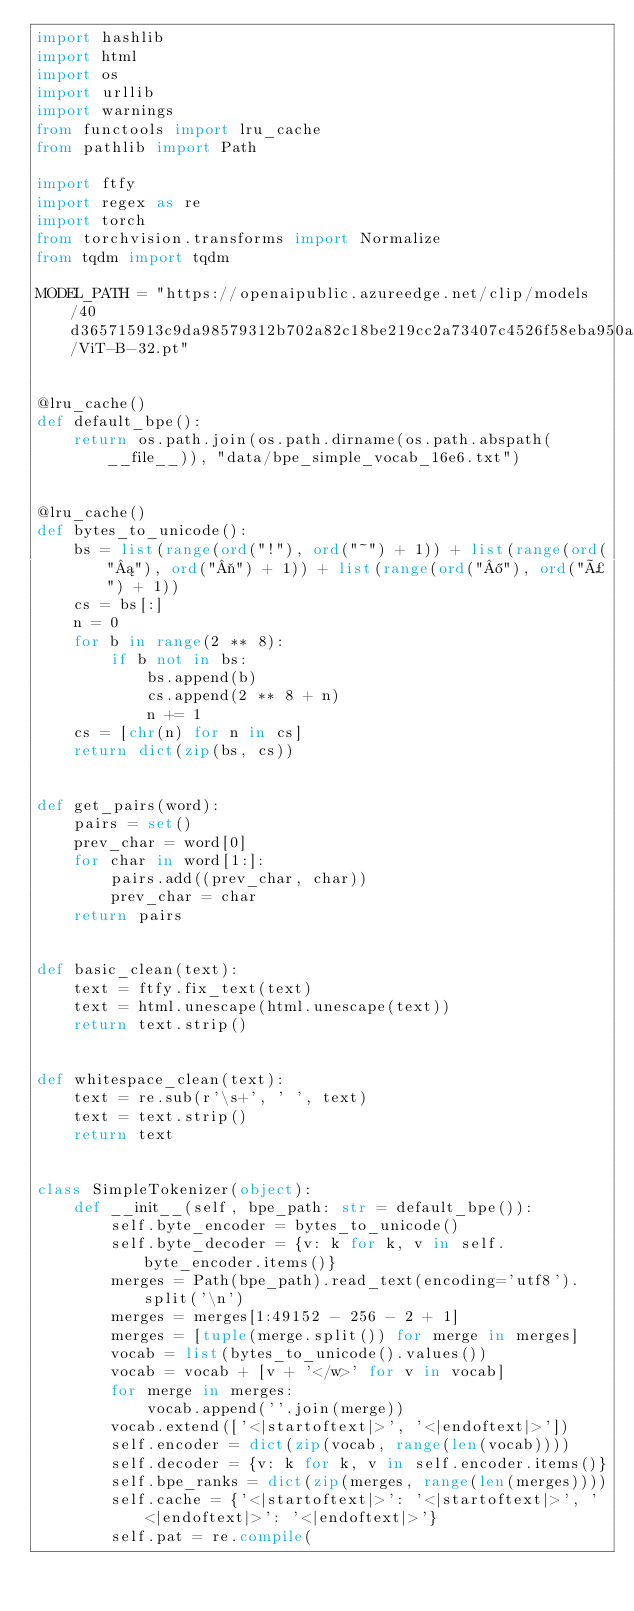<code> <loc_0><loc_0><loc_500><loc_500><_Python_>import hashlib
import html
import os
import urllib
import warnings
from functools import lru_cache
from pathlib import Path

import ftfy
import regex as re
import torch
from torchvision.transforms import Normalize
from tqdm import tqdm

MODEL_PATH = "https://openaipublic.azureedge.net/clip/models/40d365715913c9da98579312b702a82c18be219cc2a73407c4526f58eba950af/ViT-B-32.pt"


@lru_cache()
def default_bpe():
    return os.path.join(os.path.dirname(os.path.abspath(__file__)), "data/bpe_simple_vocab_16e6.txt")


@lru_cache()
def bytes_to_unicode():
    bs = list(range(ord("!"), ord("~") + 1)) + list(range(ord("¡"), ord("¬") + 1)) + list(range(ord("®"), ord("ÿ") + 1))
    cs = bs[:]
    n = 0
    for b in range(2 ** 8):
        if b not in bs:
            bs.append(b)
            cs.append(2 ** 8 + n)
            n += 1
    cs = [chr(n) for n in cs]
    return dict(zip(bs, cs))


def get_pairs(word):
    pairs = set()
    prev_char = word[0]
    for char in word[1:]:
        pairs.add((prev_char, char))
        prev_char = char
    return pairs


def basic_clean(text):
    text = ftfy.fix_text(text)
    text = html.unescape(html.unescape(text))
    return text.strip()


def whitespace_clean(text):
    text = re.sub(r'\s+', ' ', text)
    text = text.strip()
    return text


class SimpleTokenizer(object):
    def __init__(self, bpe_path: str = default_bpe()):
        self.byte_encoder = bytes_to_unicode()
        self.byte_decoder = {v: k for k, v in self.byte_encoder.items()}
        merges = Path(bpe_path).read_text(encoding='utf8').split('\n')
        merges = merges[1:49152 - 256 - 2 + 1]
        merges = [tuple(merge.split()) for merge in merges]
        vocab = list(bytes_to_unicode().values())
        vocab = vocab + [v + '</w>' for v in vocab]
        for merge in merges:
            vocab.append(''.join(merge))
        vocab.extend(['<|startoftext|>', '<|endoftext|>'])
        self.encoder = dict(zip(vocab, range(len(vocab))))
        self.decoder = {v: k for k, v in self.encoder.items()}
        self.bpe_ranks = dict(zip(merges, range(len(merges))))
        self.cache = {'<|startoftext|>': '<|startoftext|>', '<|endoftext|>': '<|endoftext|>'}
        self.pat = re.compile(</code> 